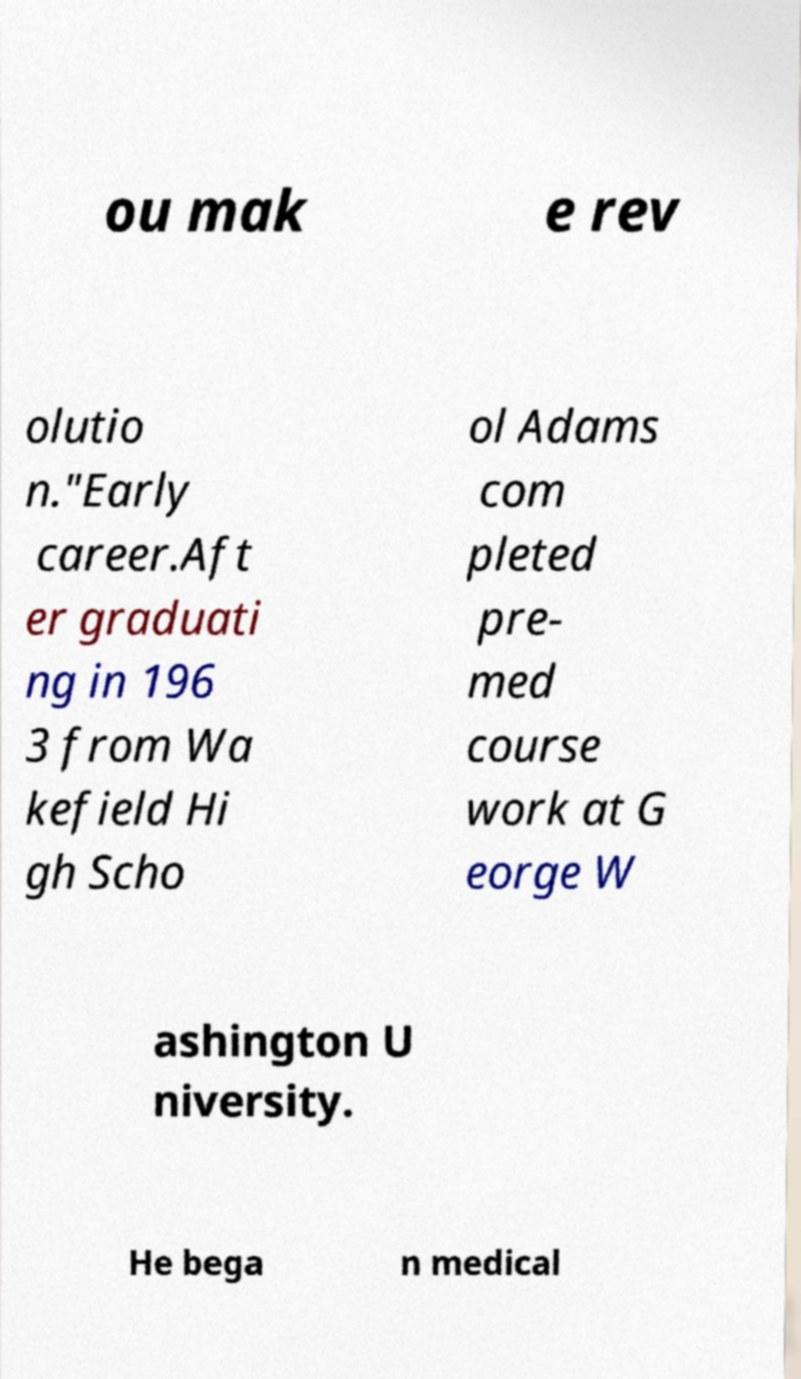There's text embedded in this image that I need extracted. Can you transcribe it verbatim? ou mak e rev olutio n."Early career.Aft er graduati ng in 196 3 from Wa kefield Hi gh Scho ol Adams com pleted pre- med course work at G eorge W ashington U niversity. He bega n medical 